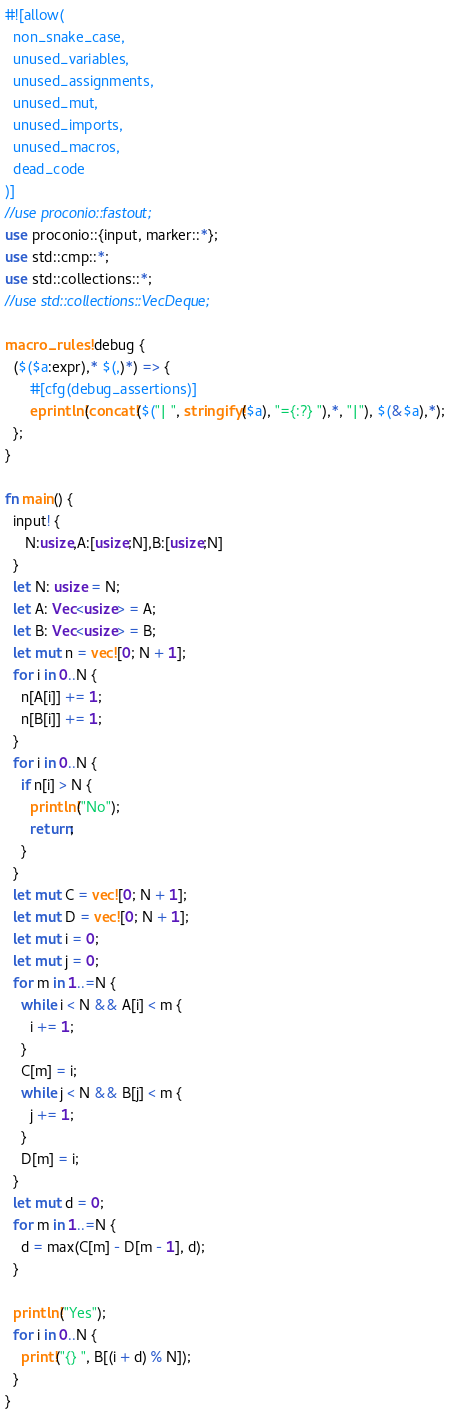<code> <loc_0><loc_0><loc_500><loc_500><_Rust_>#![allow(
  non_snake_case,
  unused_variables,
  unused_assignments,
  unused_mut,
  unused_imports,
  unused_macros,
  dead_code
)]
//use proconio::fastout;
use proconio::{input, marker::*};
use std::cmp::*;
use std::collections::*;
//use std::collections::VecDeque;

macro_rules! debug {
  ($($a:expr),* $(,)*) => {
      #[cfg(debug_assertions)]
      eprintln!(concat!($("| ", stringify!($a), "={:?} "),*, "|"), $(&$a),*);
  };
}

fn main() {
  input! {
     N:usize,A:[usize;N],B:[usize;N]
  }
  let N: usize = N;
  let A: Vec<usize> = A;
  let B: Vec<usize> = B;
  let mut n = vec![0; N + 1];
  for i in 0..N {
    n[A[i]] += 1;
    n[B[i]] += 1;
  }
  for i in 0..N {
    if n[i] > N {
      println!("No");
      return;
    }
  }
  let mut C = vec![0; N + 1];
  let mut D = vec![0; N + 1];
  let mut i = 0;
  let mut j = 0;
  for m in 1..=N {
    while i < N && A[i] < m {
      i += 1;
    }
    C[m] = i;
    while j < N && B[j] < m {
      j += 1;
    }
    D[m] = i;
  }
  let mut d = 0;
  for m in 1..=N {
    d = max(C[m] - D[m - 1], d);
  }

  println!("Yes");
  for i in 0..N {
    print!("{} ", B[(i + d) % N]);
  }
}
</code> 